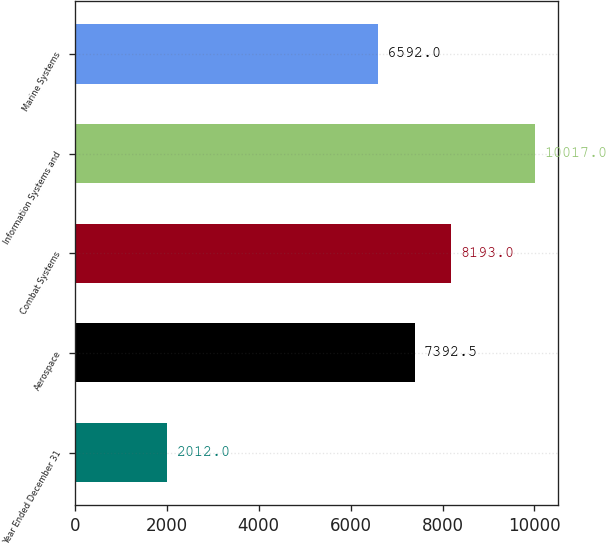Convert chart. <chart><loc_0><loc_0><loc_500><loc_500><bar_chart><fcel>Year Ended December 31<fcel>Aerospace<fcel>Combat Systems<fcel>Information Systems and<fcel>Marine Systems<nl><fcel>2012<fcel>7392.5<fcel>8193<fcel>10017<fcel>6592<nl></chart> 